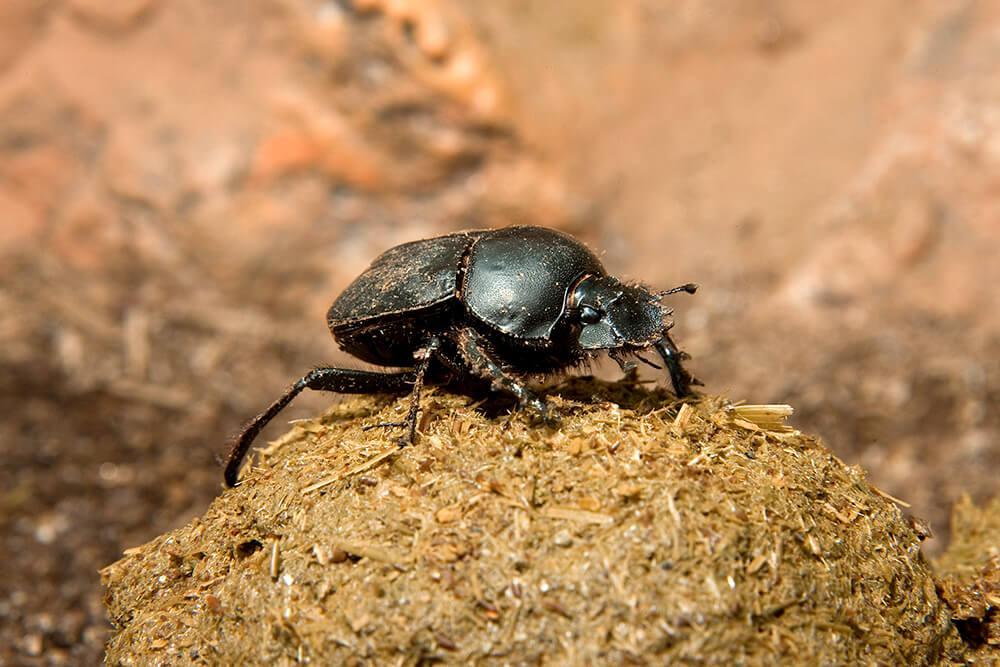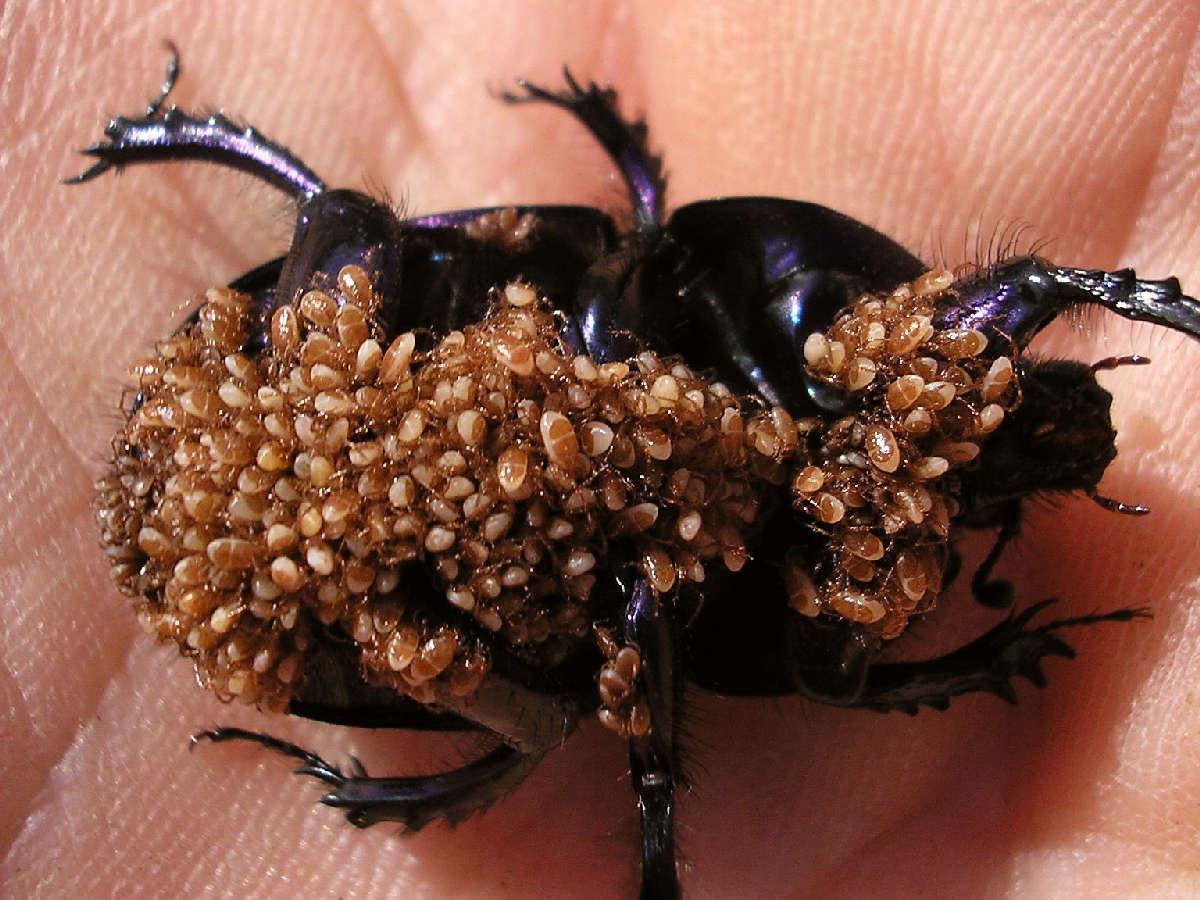The first image is the image on the left, the second image is the image on the right. Examine the images to the left and right. Is the description "There are two beetles on the clod of dirt in the image on the right." accurate? Answer yes or no. No. The first image is the image on the left, the second image is the image on the right. Considering the images on both sides, is "An image shows a dungball with two beetles on it, and one beetle has no part touching the ground." valid? Answer yes or no. No. 